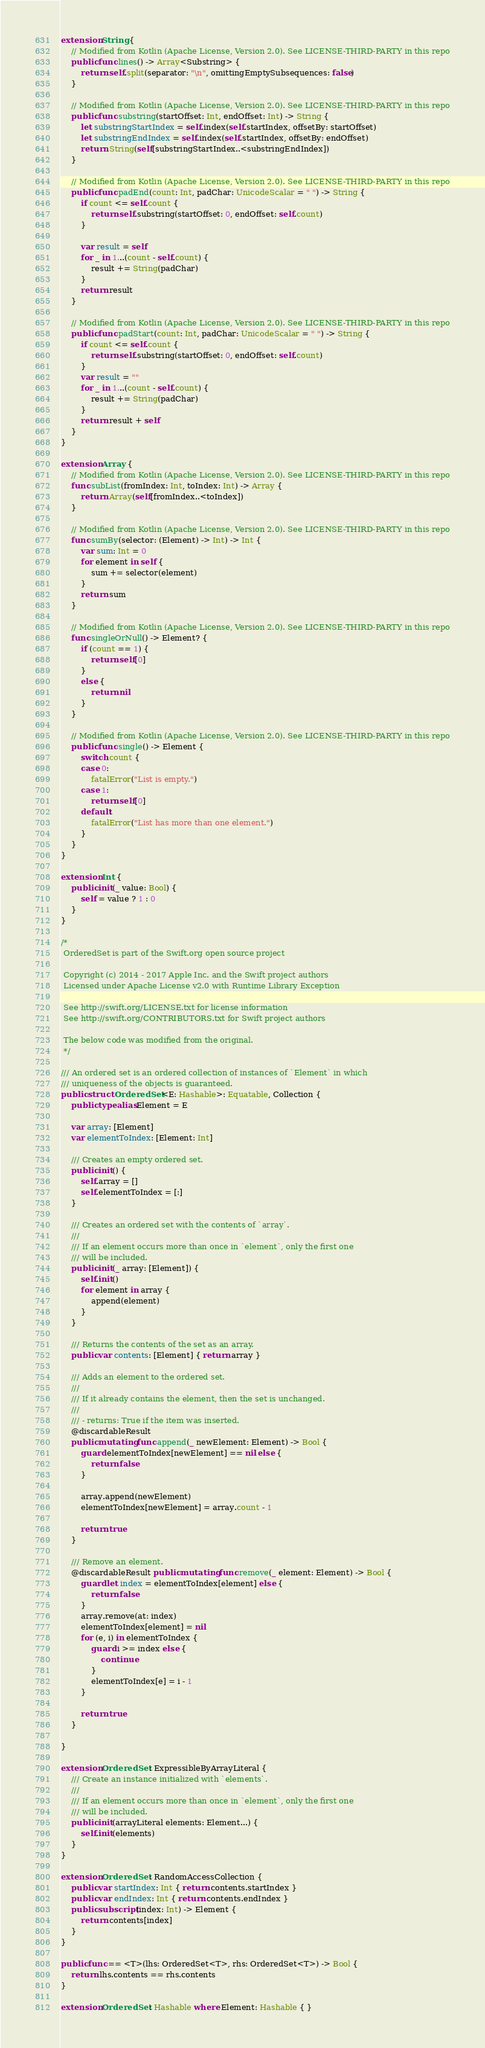<code> <loc_0><loc_0><loc_500><loc_500><_Swift_>extension String {
    // Modified from Kotlin (Apache License, Version 2.0). See LICENSE-THIRD-PARTY in this repo
    public func lines() -> Array<Substring> {
        return self.split(separator: "\n", omittingEmptySubsequences: false)
    }
    
    // Modified from Kotlin (Apache License, Version 2.0). See LICENSE-THIRD-PARTY in this repo
    public func substring(startOffset: Int, endOffset: Int) -> String {
        let substringStartIndex = self.index(self.startIndex, offsetBy: startOffset)
        let substringEndIndex = self.index(self.startIndex, offsetBy: endOffset)
        return String(self[substringStartIndex..<substringEndIndex])
    }
    
    // Modified from Kotlin (Apache License, Version 2.0). See LICENSE-THIRD-PARTY in this repo
    public func padEnd(count: Int, padChar: UnicodeScalar = " ") -> String {
        if count <= self.count {
            return self.substring(startOffset: 0, endOffset: self.count)
        }
        
        var result = self
        for _ in 1...(count - self.count) {
            result += String(padChar)
        }
        return result
    }
    
    // Modified from Kotlin (Apache License, Version 2.0). See LICENSE-THIRD-PARTY in this repo
    public func padStart(count: Int, padChar: UnicodeScalar = " ") -> String {
        if count <= self.count {
            return self.substring(startOffset: 0, endOffset: self.count)
        }
        var result = ""
        for _ in 1...(count - self.count) {
            result += String(padChar)
        }
        return result + self
    }
}

extension Array {
    // Modified from Kotlin (Apache License, Version 2.0). See LICENSE-THIRD-PARTY in this repo
    func subList(fromIndex: Int, toIndex: Int) -> Array {
        return Array(self[fromIndex..<toIndex])
    }
    
    // Modified from Kotlin (Apache License, Version 2.0). See LICENSE-THIRD-PARTY in this repo
    func sumBy(selector: (Element) -> Int) -> Int {
        var sum: Int = 0
        for element in self {
            sum += selector(element)
        }
        return sum
    }
    
    // Modified from Kotlin (Apache License, Version 2.0). See LICENSE-THIRD-PARTY in this repo
    func singleOrNull() -> Element? {
        if (count == 1) {
            return self[0]
        }
        else {
            return nil
        }
    }
    
    // Modified from Kotlin (Apache License, Version 2.0). See LICENSE-THIRD-PARTY in this repo
    public func single() -> Element {
        switch count {
        case 0:
            fatalError("List is empty.")
        case 1:
            return self[0]
        default:
            fatalError("List has more than one element.")
        }
    }
}

extension Int {
    public init(_ value: Bool) {
        self = value ? 1 : 0
    }
}

/*
 OrderedSet is part of the Swift.org open source project
 
 Copyright (c) 2014 - 2017 Apple Inc. and the Swift project authors
 Licensed under Apache License v2.0 with Runtime Library Exception
 
 See http://swift.org/LICENSE.txt for license information
 See http://swift.org/CONTRIBUTORS.txt for Swift project authors
 
 The below code was modified from the original.
 */

/// An ordered set is an ordered collection of instances of `Element` in which
/// uniqueness of the objects is guaranteed.
public struct OrderedSet<E: Hashable>: Equatable, Collection {
    public typealias Element = E
    
    var array: [Element]
    var elementToIndex: [Element: Int]
    
    /// Creates an empty ordered set.
    public init() {
        self.array = []
        self.elementToIndex = [:]
    }
    
    /// Creates an ordered set with the contents of `array`.
    ///
    /// If an element occurs more than once in `element`, only the first one
    /// will be included.
    public init(_ array: [Element]) {
        self.init()
        for element in array {
            append(element)
        }
    }
    
    /// Returns the contents of the set as an array.
    public var contents: [Element] { return array }
    
    /// Adds an element to the ordered set.
    ///
    /// If it already contains the element, then the set is unchanged.
    ///
    /// - returns: True if the item was inserted.
    @discardableResult
    public mutating func append(_ newElement: Element) -> Bool {
        guard elementToIndex[newElement] == nil else {
            return false
        }
        
        array.append(newElement)
        elementToIndex[newElement] = array.count - 1
        
        return true
    }
    
    /// Remove an element.
    @discardableResult public mutating func remove(_ element: Element) -> Bool {
        guard let index = elementToIndex[element] else {
            return false
        }
        array.remove(at: index)
        elementToIndex[element] = nil
        for (e, i) in elementToIndex {
            guard i >= index else {
                continue
            }
            elementToIndex[e] = i - 1
        }
        
        return true
    }

}

extension OrderedSet: ExpressibleByArrayLiteral {
    /// Create an instance initialized with `elements`.
    ///
    /// If an element occurs more than once in `element`, only the first one
    /// will be included.
    public init(arrayLiteral elements: Element...) {
        self.init(elements)
    }
}

extension OrderedSet: RandomAccessCollection {
    public var startIndex: Int { return contents.startIndex }
    public var endIndex: Int { return contents.endIndex }
    public subscript(index: Int) -> Element {
        return contents[index]
    }
}

public func == <T>(lhs: OrderedSet<T>, rhs: OrderedSet<T>) -> Bool {
    return lhs.contents == rhs.contents
}

extension OrderedSet: Hashable where Element: Hashable { }
</code> 